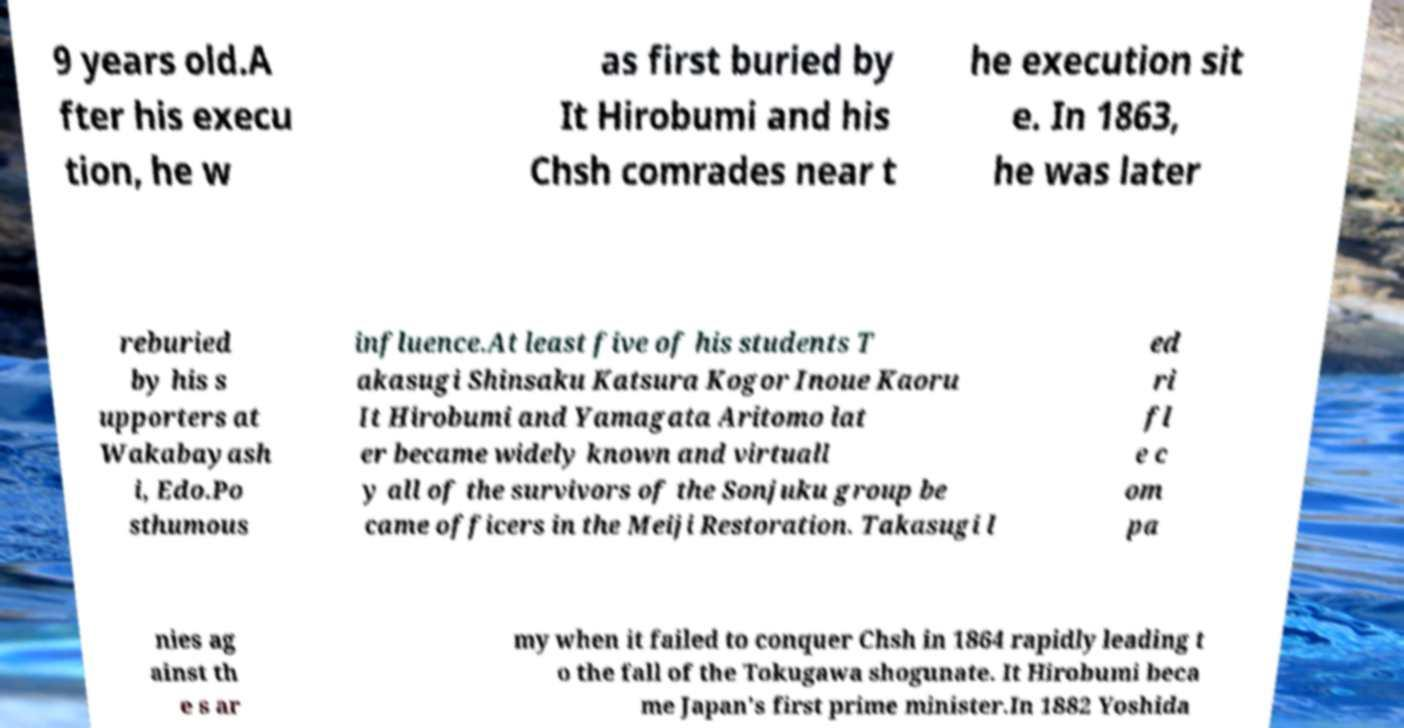There's text embedded in this image that I need extracted. Can you transcribe it verbatim? 9 years old.A fter his execu tion, he w as first buried by It Hirobumi and his Chsh comrades near t he execution sit e. In 1863, he was later reburied by his s upporters at Wakabayash i, Edo.Po sthumous influence.At least five of his students T akasugi Shinsaku Katsura Kogor Inoue Kaoru It Hirobumi and Yamagata Aritomo lat er became widely known and virtuall y all of the survivors of the Sonjuku group be came officers in the Meiji Restoration. Takasugi l ed ri fl e c om pa nies ag ainst th e s ar my when it failed to conquer Chsh in 1864 rapidly leading t o the fall of the Tokugawa shogunate. It Hirobumi beca me Japan's first prime minister.In 1882 Yoshida 